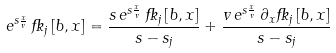<formula> <loc_0><loc_0><loc_500><loc_500>e ^ { s \frac { x } { v } } \, \Psi _ { j } \left [ b , x \right ] = \frac { s \, e ^ { s \frac { x } { v } } \, \Psi _ { j } \left [ b , x \right ] } { s - s _ { j } } + \frac { v \, e ^ { s \frac { x } { v } } \, \partial _ { x } \Psi _ { j } \left [ b , x \right ] } { s - s _ { j } }</formula> 